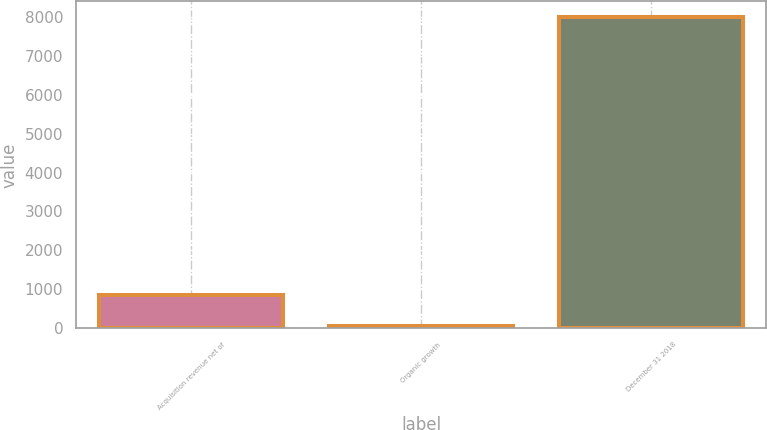<chart> <loc_0><loc_0><loc_500><loc_500><bar_chart><fcel>Acquisition revenue net of<fcel>Organic growth<fcel>December 31 2018<nl><fcel>852.18<fcel>58<fcel>7999.8<nl></chart> 